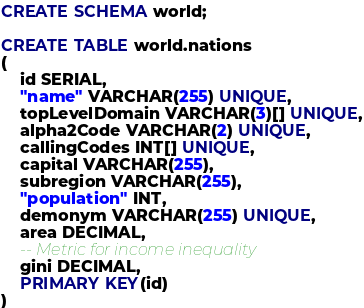<code> <loc_0><loc_0><loc_500><loc_500><_SQL_>
CREATE SCHEMA world;

CREATE TABLE world.nations
(
    id SERIAL,
    "name" VARCHAR(255) UNIQUE,
    topLevelDomain VARCHAR(3)[] UNIQUE,
    alpha2Code VARCHAR(2) UNIQUE,
    callingCodes INT[] UNIQUE,
    capital VARCHAR(255),
    subregion VARCHAR(255),
    "population" INT,
    demonym VARCHAR(255) UNIQUE,
    area DECIMAL,
    -- Metric for income inequality
    gini DECIMAL,
    PRIMARY KEY(id)
)
</code> 